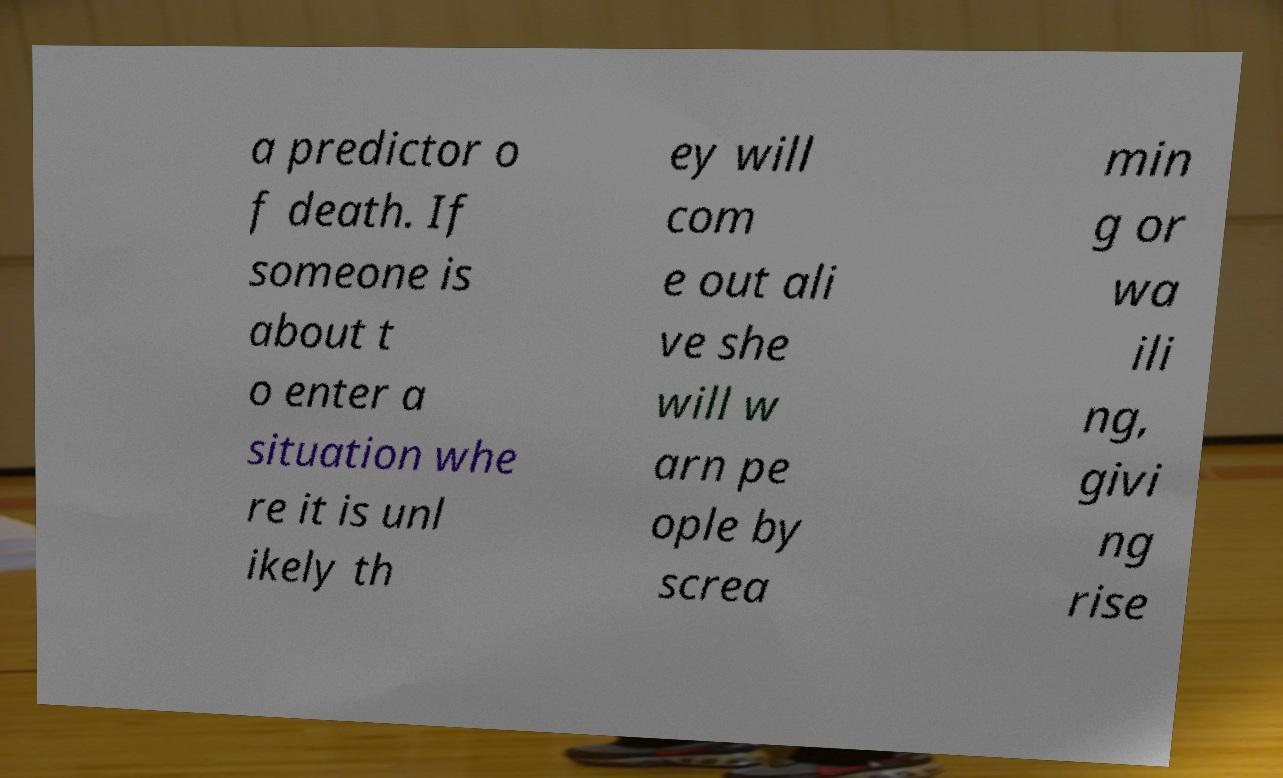What messages or text are displayed in this image? I need them in a readable, typed format. a predictor o f death. If someone is about t o enter a situation whe re it is unl ikely th ey will com e out ali ve she will w arn pe ople by screa min g or wa ili ng, givi ng rise 